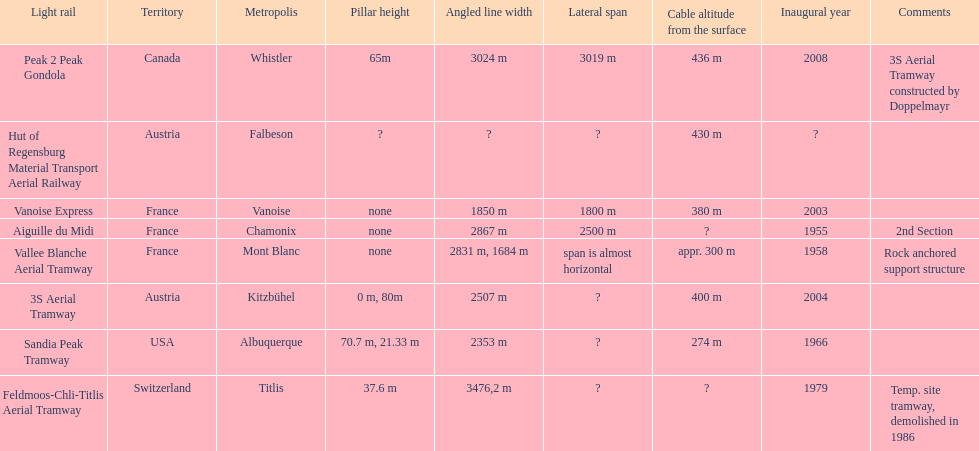Was the sandia peak tramway innagurate before or after the 3s aerial tramway? Before. 